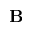<formula> <loc_0><loc_0><loc_500><loc_500>B</formula> 